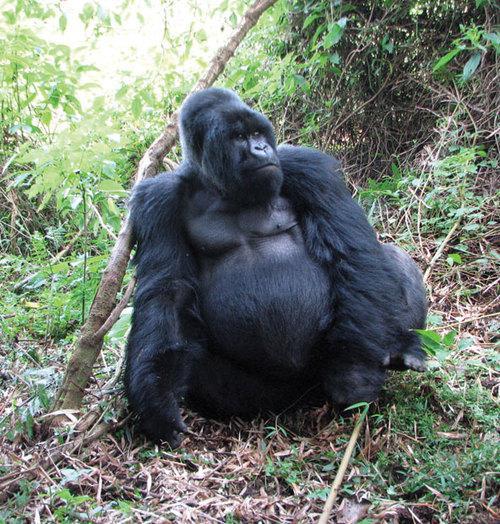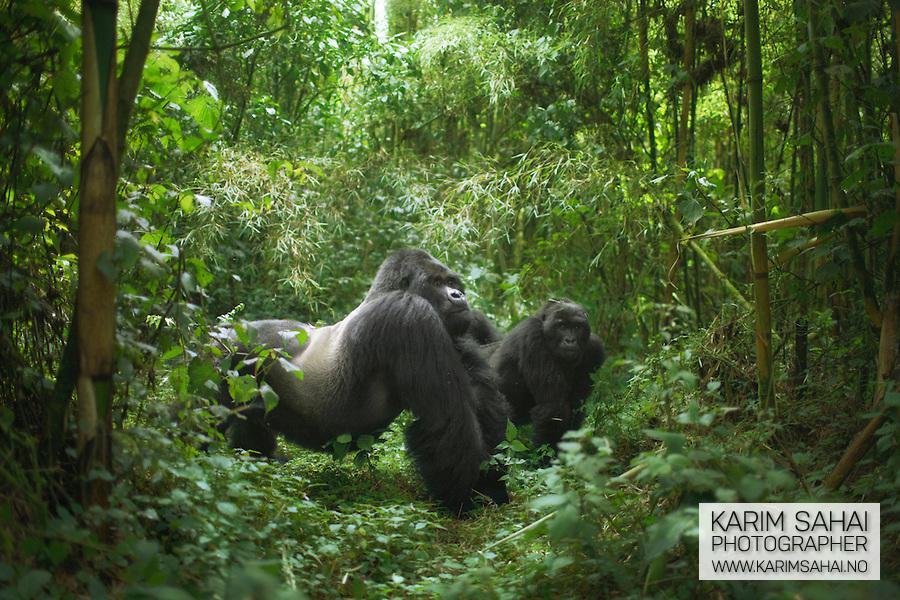The first image is the image on the left, the second image is the image on the right. For the images displayed, is the sentence "The gorilla in the left image is very close to another gorilla." factually correct? Answer yes or no. No. The first image is the image on the left, the second image is the image on the right. Assess this claim about the two images: "There is a single ape in the right image.". Correct or not? Answer yes or no. No. 